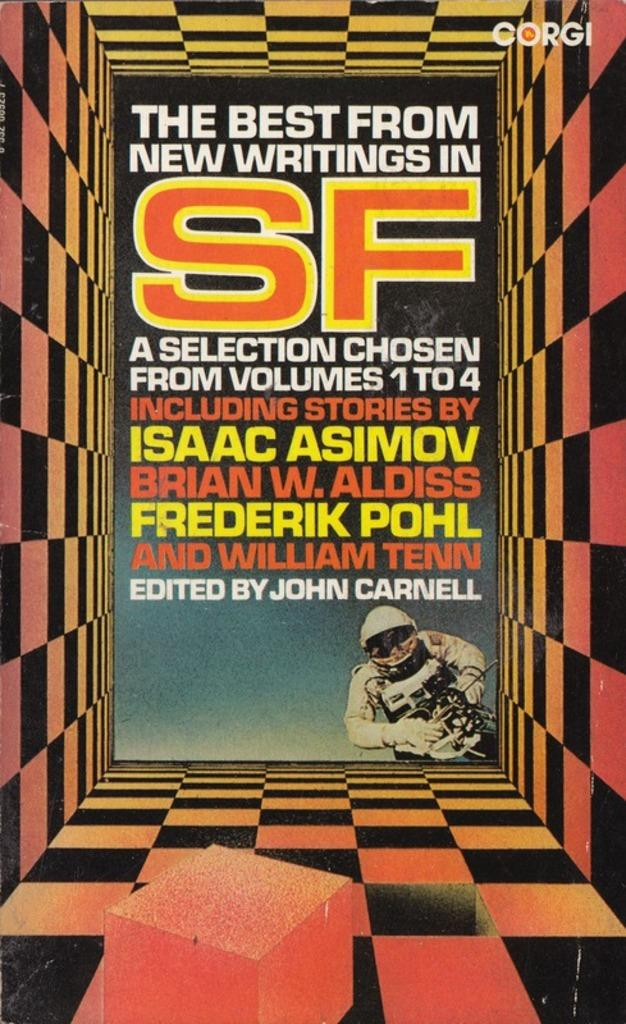<image>
Present a compact description of the photo's key features. A book cover titled The Best From New Writings in SF. 